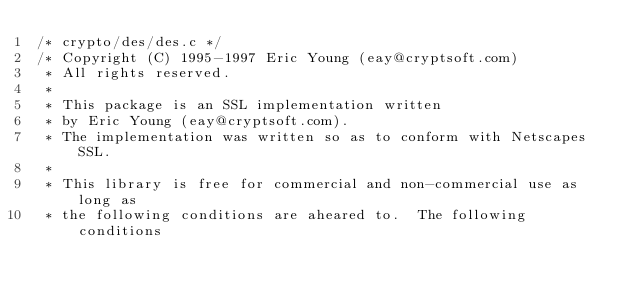Convert code to text. <code><loc_0><loc_0><loc_500><loc_500><_C_>/* crypto/des/des.c */
/* Copyright (C) 1995-1997 Eric Young (eay@cryptsoft.com)
 * All rights reserved.
 *
 * This package is an SSL implementation written
 * by Eric Young (eay@cryptsoft.com).
 * The implementation was written so as to conform with Netscapes SSL.
 * 
 * This library is free for commercial and non-commercial use as long as
 * the following conditions are aheared to.  The following conditions</code> 